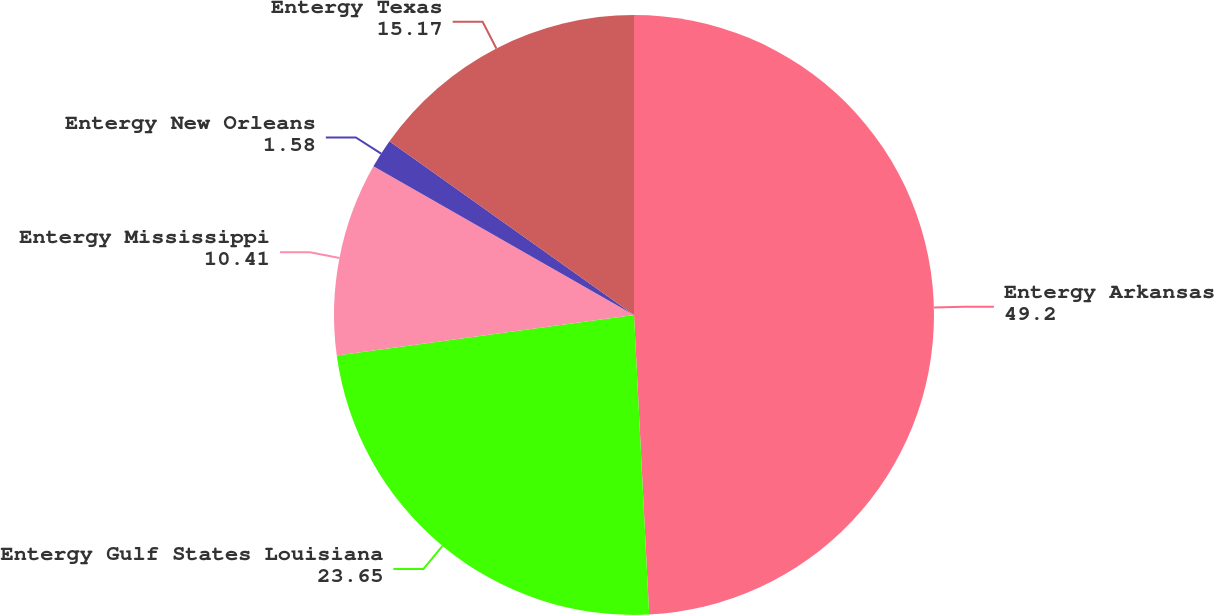Convert chart. <chart><loc_0><loc_0><loc_500><loc_500><pie_chart><fcel>Entergy Arkansas<fcel>Entergy Gulf States Louisiana<fcel>Entergy Mississippi<fcel>Entergy New Orleans<fcel>Entergy Texas<nl><fcel>49.2%<fcel>23.65%<fcel>10.41%<fcel>1.58%<fcel>15.17%<nl></chart> 